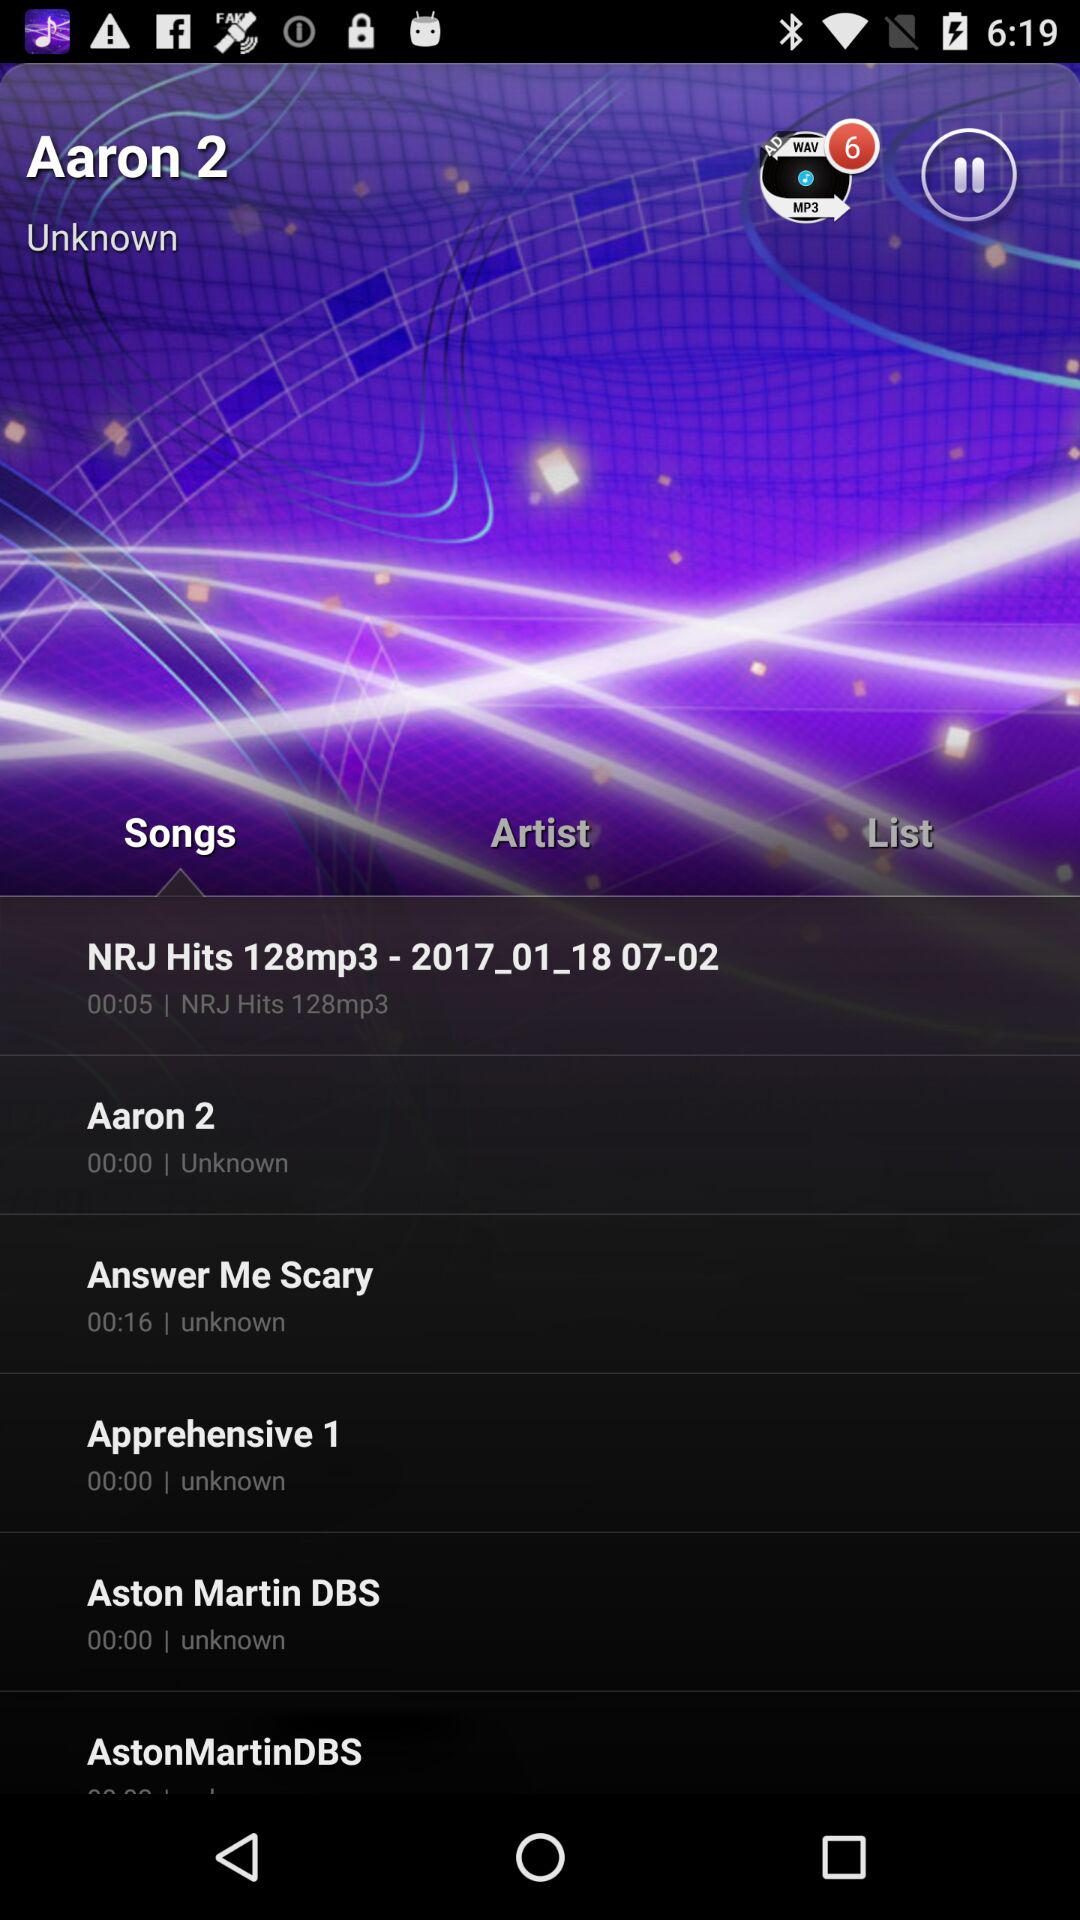What tab is currently selected? The selected tab is "Songs". 